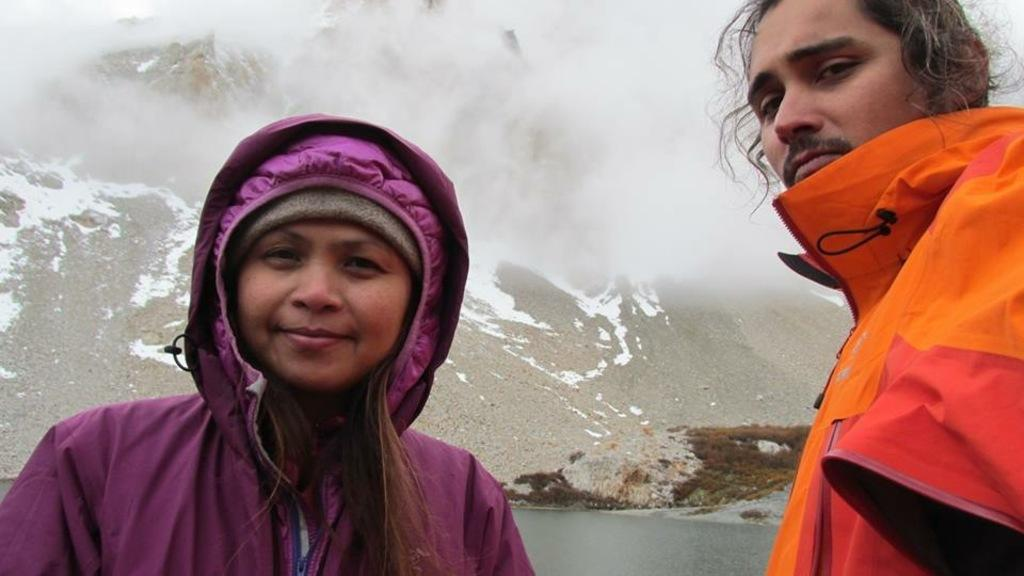How many people are in the image? There are two people in the image. What colors are the coats of the people in the image? One person is wearing a purple coat, and the other person is wearing an orange coat. What can be seen in the background of the image? Mountains, water, and fog are visible in the background. What type of tax is being discussed by the people in the image? There is no indication in the image that the people are discussing any type of tax. 